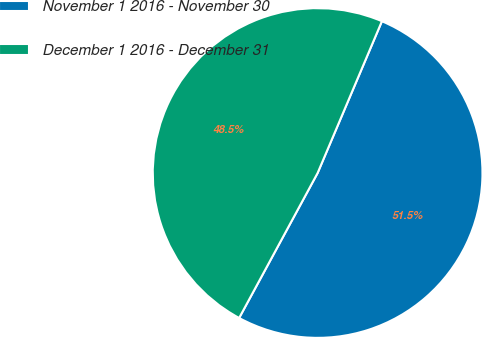Convert chart. <chart><loc_0><loc_0><loc_500><loc_500><pie_chart><fcel>November 1 2016 - November 30<fcel>December 1 2016 - December 31<nl><fcel>51.52%<fcel>48.48%<nl></chart> 